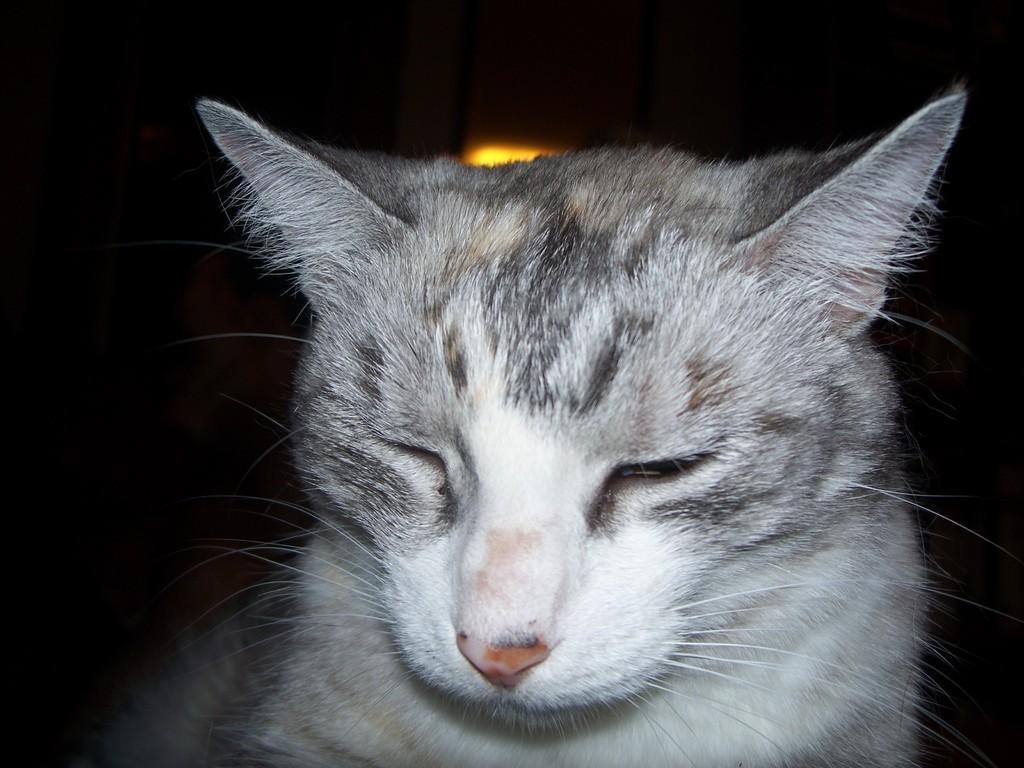Describe this image in one or two sentences. In this picture we can see a cat, light and in the background it is dark. 